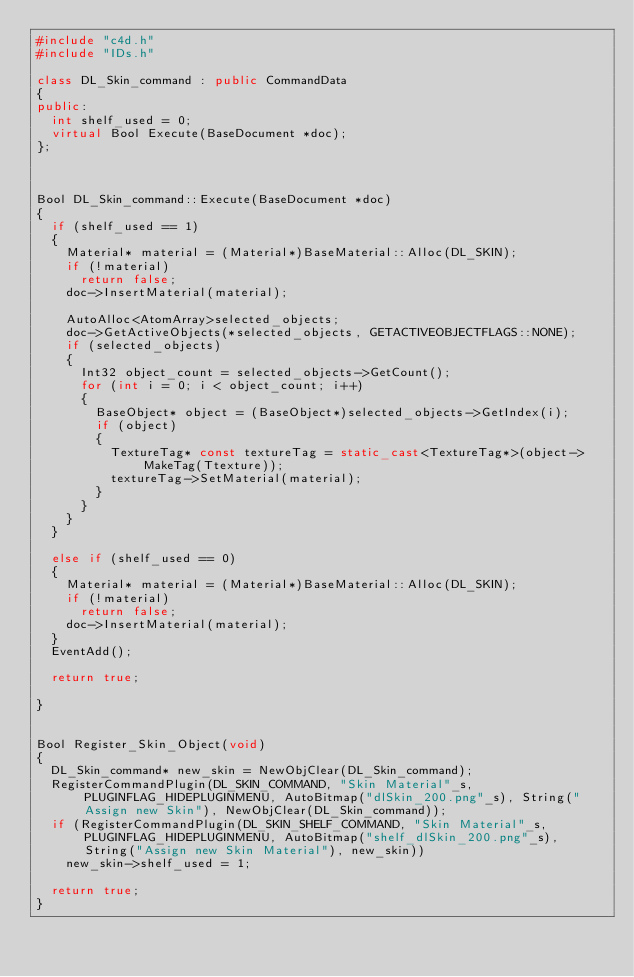<code> <loc_0><loc_0><loc_500><loc_500><_C++_>#include "c4d.h"
#include "IDs.h"

class DL_Skin_command : public CommandData
{
public:
	int shelf_used = 0;
	virtual Bool Execute(BaseDocument *doc);
};



Bool DL_Skin_command::Execute(BaseDocument *doc)
{
	if (shelf_used == 1)
	{
		Material* material = (Material*)BaseMaterial::Alloc(DL_SKIN);
		if (!material)
			return false;
		doc->InsertMaterial(material);

		AutoAlloc<AtomArray>selected_objects;
		doc->GetActiveObjects(*selected_objects, GETACTIVEOBJECTFLAGS::NONE);
		if (selected_objects)
		{
			Int32 object_count = selected_objects->GetCount();
			for (int i = 0; i < object_count; i++)
			{
				BaseObject* object = (BaseObject*)selected_objects->GetIndex(i);
				if (object)
				{
					TextureTag* const textureTag = static_cast<TextureTag*>(object->MakeTag(Ttexture));
					textureTag->SetMaterial(material);
				}
			}
		}
	}

	else if (shelf_used == 0)
	{
		Material* material = (Material*)BaseMaterial::Alloc(DL_SKIN);
		if (!material)
			return false;
		doc->InsertMaterial(material);
	}
	EventAdd();

	return true;
	
}


Bool Register_Skin_Object(void)
{
	DL_Skin_command* new_skin = NewObjClear(DL_Skin_command);
	RegisterCommandPlugin(DL_SKIN_COMMAND, "Skin Material"_s, PLUGINFLAG_HIDEPLUGINMENU, AutoBitmap("dlSkin_200.png"_s), String("Assign new Skin"), NewObjClear(DL_Skin_command));
	if (RegisterCommandPlugin(DL_SKIN_SHELF_COMMAND, "Skin Material"_s, PLUGINFLAG_HIDEPLUGINMENU, AutoBitmap("shelf_dlSkin_200.png"_s), String("Assign new Skin Material"), new_skin))
		new_skin->shelf_used = 1;

	return true;
}
</code> 